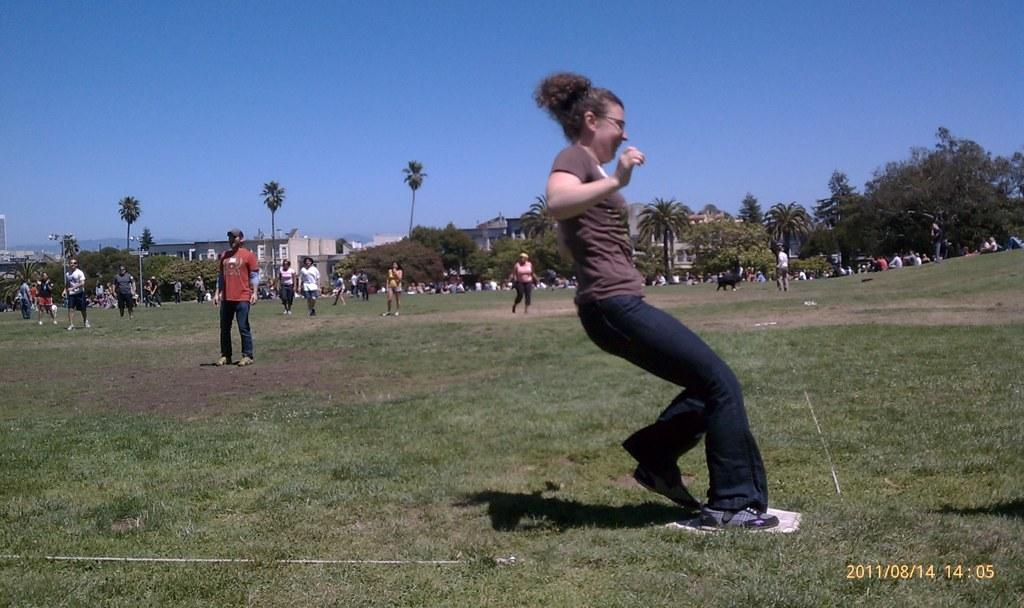What is happening on the ground in the image? There are people on the ground in the image. What can be seen in the background of the image? There are trees, buildings, and poles in the background of the image. What is visible at the top of the image? The sky is visible at the top of the image. What is written or displayed at the bottom of the image? There is some text at the bottom of the image. What type of liquid is being judged by the people in the image? There is no liquid or judging activity present in the image; it features people on the ground with trees, buildings, and poles in the background. What show is being performed by the people in the image? There is no show or performance happening in the image; it simply shows people on the ground with text at the bottom and the sky visible at the top. 